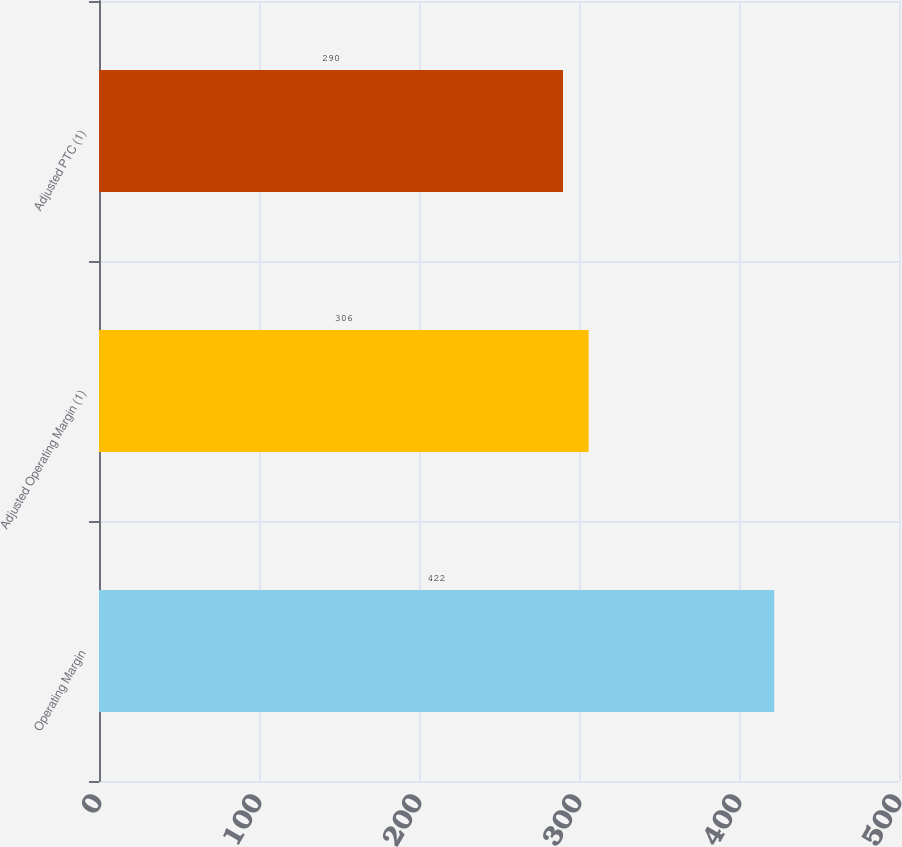<chart> <loc_0><loc_0><loc_500><loc_500><bar_chart><fcel>Operating Margin<fcel>Adjusted Operating Margin (1)<fcel>Adjusted PTC (1)<nl><fcel>422<fcel>306<fcel>290<nl></chart> 